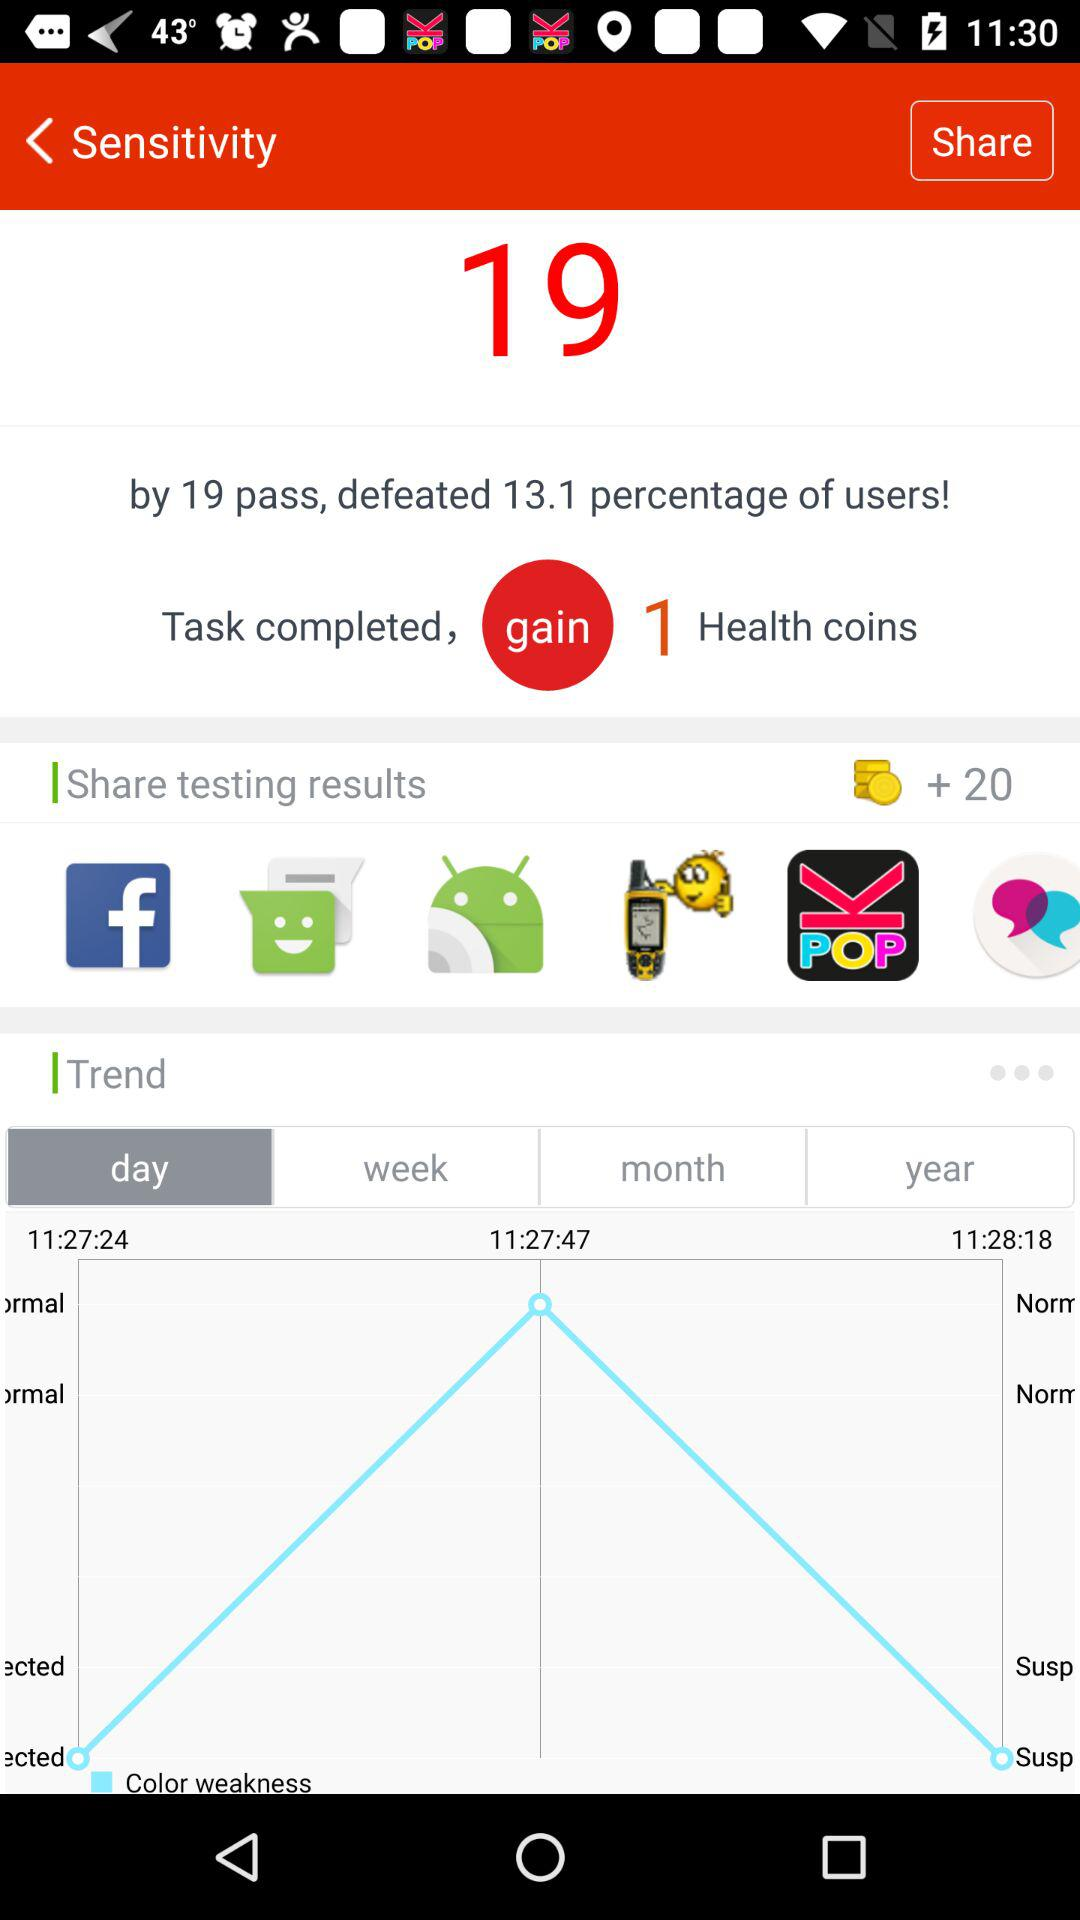What's the percentage of users who are defeated by 19 pass? The percentage is 13.1. 